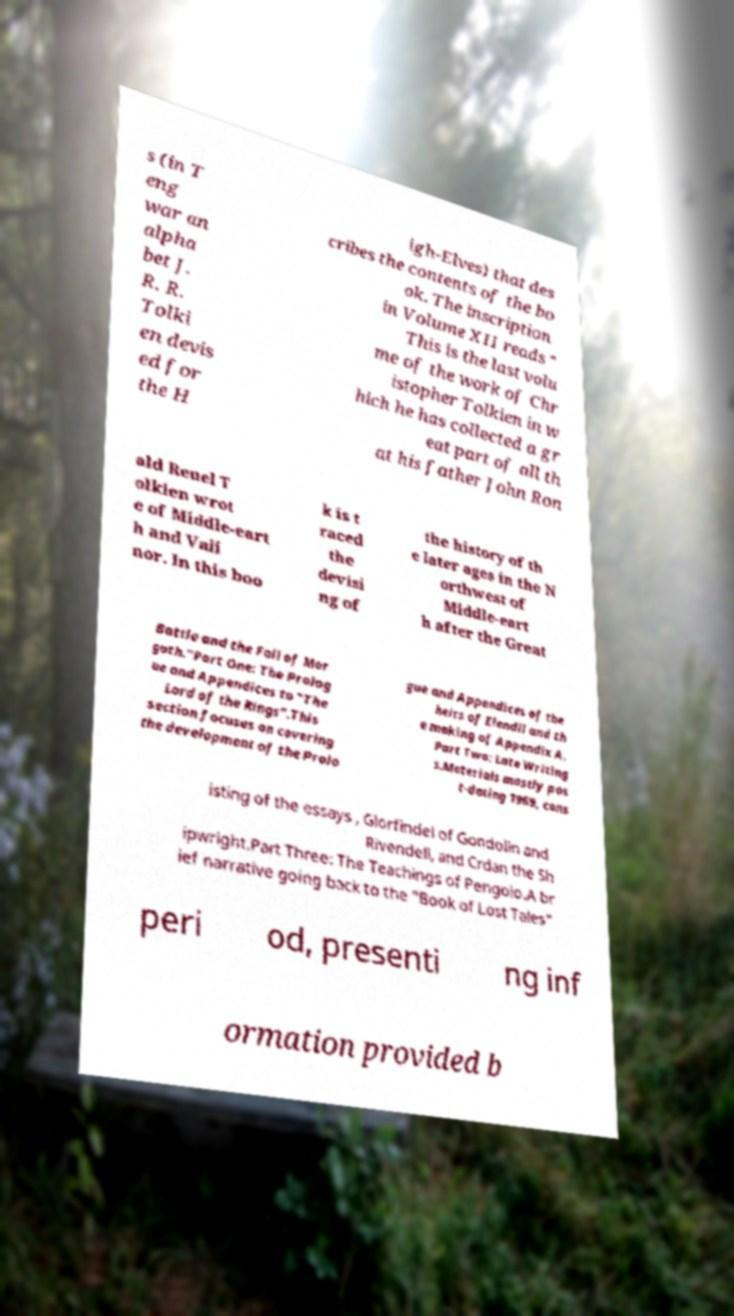Please identify and transcribe the text found in this image. s (in T eng war an alpha bet J. R. R. Tolki en devis ed for the H igh-Elves) that des cribes the contents of the bo ok. The inscription in Volume XII reads " This is the last volu me of the work of Chr istopher Tolkien in w hich he has collected a gr eat part of all th at his father John Ron ald Reuel T olkien wrot e of Middle-eart h and Vali nor. In this boo k is t raced the devisi ng of the history of th e later ages in the N orthwest of Middle-eart h after the Great Battle and the Fall of Mor goth."Part One: The Prolog ue and Appendices to "The Lord of the Rings".This section focuses on covering the development of the Prolo gue and Appendices of the heirs of Elendil and th e making of Appendix A. Part Two: Late Writing s.Materials mostly pos t-dating 1969, cons isting of the essays , Glorfindel of Gondolin and Rivendell, and Crdan the Sh ipwright.Part Three: The Teachings of Pengolo.A br ief narrative going back to the "Book of Lost Tales" peri od, presenti ng inf ormation provided b 